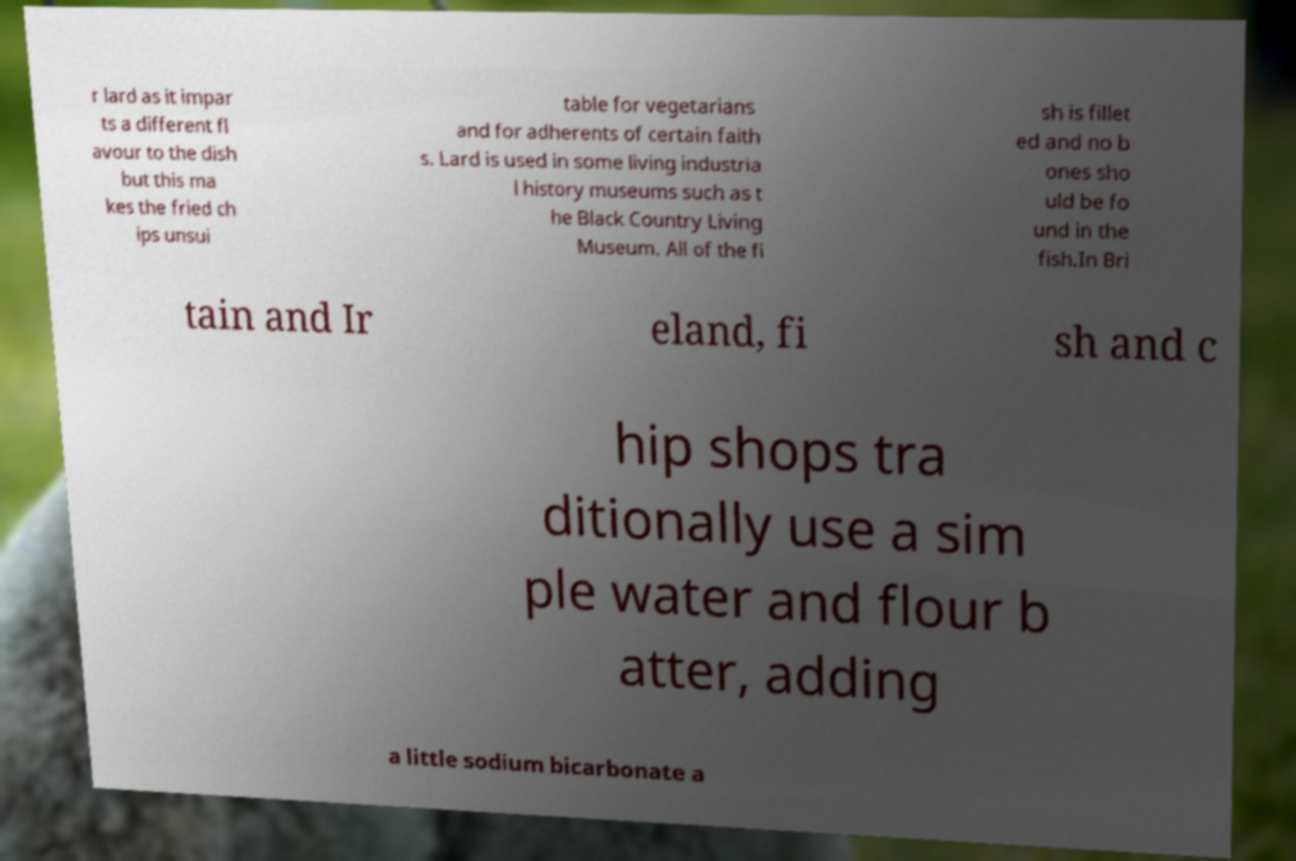Could you extract and type out the text from this image? r lard as it impar ts a different fl avour to the dish but this ma kes the fried ch ips unsui table for vegetarians and for adherents of certain faith s. Lard is used in some living industria l history museums such as t he Black Country Living Museum. All of the fi sh is fillet ed and no b ones sho uld be fo und in the fish.In Bri tain and Ir eland, fi sh and c hip shops tra ditionally use a sim ple water and flour b atter, adding a little sodium bicarbonate a 